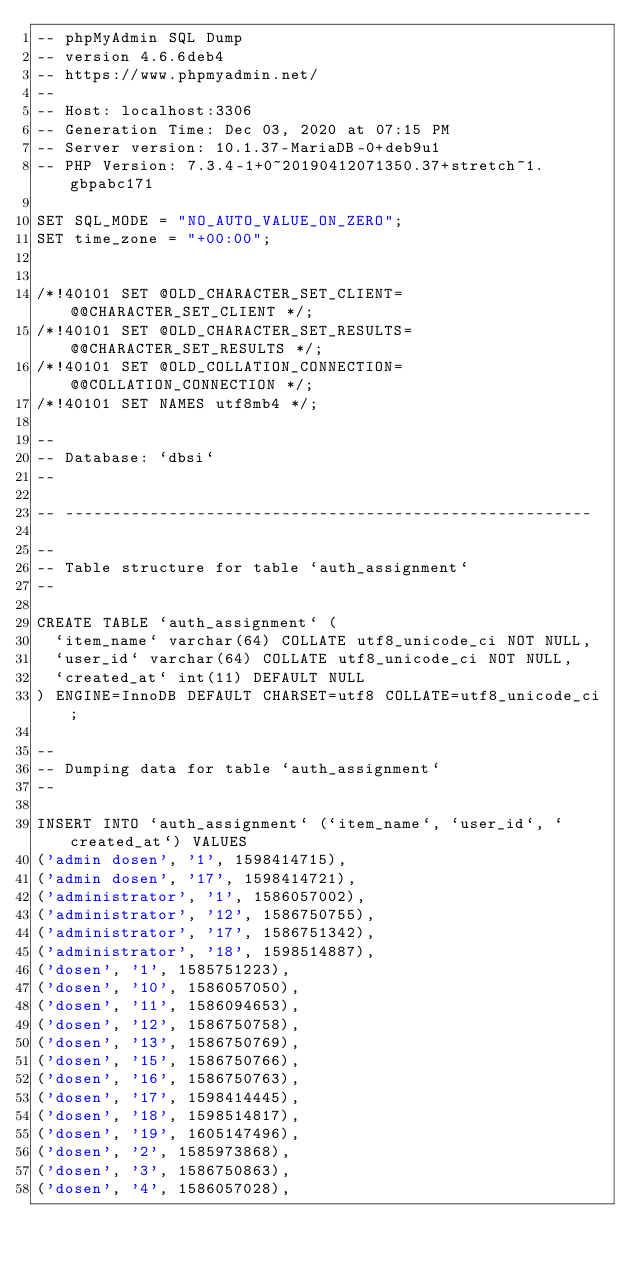<code> <loc_0><loc_0><loc_500><loc_500><_SQL_>-- phpMyAdmin SQL Dump
-- version 4.6.6deb4
-- https://www.phpmyadmin.net/
--
-- Host: localhost:3306
-- Generation Time: Dec 03, 2020 at 07:15 PM
-- Server version: 10.1.37-MariaDB-0+deb9u1
-- PHP Version: 7.3.4-1+0~20190412071350.37+stretch~1.gbpabc171

SET SQL_MODE = "NO_AUTO_VALUE_ON_ZERO";
SET time_zone = "+00:00";


/*!40101 SET @OLD_CHARACTER_SET_CLIENT=@@CHARACTER_SET_CLIENT */;
/*!40101 SET @OLD_CHARACTER_SET_RESULTS=@@CHARACTER_SET_RESULTS */;
/*!40101 SET @OLD_COLLATION_CONNECTION=@@COLLATION_CONNECTION */;
/*!40101 SET NAMES utf8mb4 */;

--
-- Database: `dbsi`
--

-- --------------------------------------------------------

--
-- Table structure for table `auth_assignment`
--

CREATE TABLE `auth_assignment` (
  `item_name` varchar(64) COLLATE utf8_unicode_ci NOT NULL,
  `user_id` varchar(64) COLLATE utf8_unicode_ci NOT NULL,
  `created_at` int(11) DEFAULT NULL
) ENGINE=InnoDB DEFAULT CHARSET=utf8 COLLATE=utf8_unicode_ci;

--
-- Dumping data for table `auth_assignment`
--

INSERT INTO `auth_assignment` (`item_name`, `user_id`, `created_at`) VALUES
('admin dosen', '1', 1598414715),
('admin dosen', '17', 1598414721),
('administrator', '1', 1586057002),
('administrator', '12', 1586750755),
('administrator', '17', 1586751342),
('administrator', '18', 1598514887),
('dosen', '1', 1585751223),
('dosen', '10', 1586057050),
('dosen', '11', 1586094653),
('dosen', '12', 1586750758),
('dosen', '13', 1586750769),
('dosen', '15', 1586750766),
('dosen', '16', 1586750763),
('dosen', '17', 1598414445),
('dosen', '18', 1598514817),
('dosen', '19', 1605147496),
('dosen', '2', 1585973868),
('dosen', '3', 1586750863),
('dosen', '4', 1586057028),</code> 